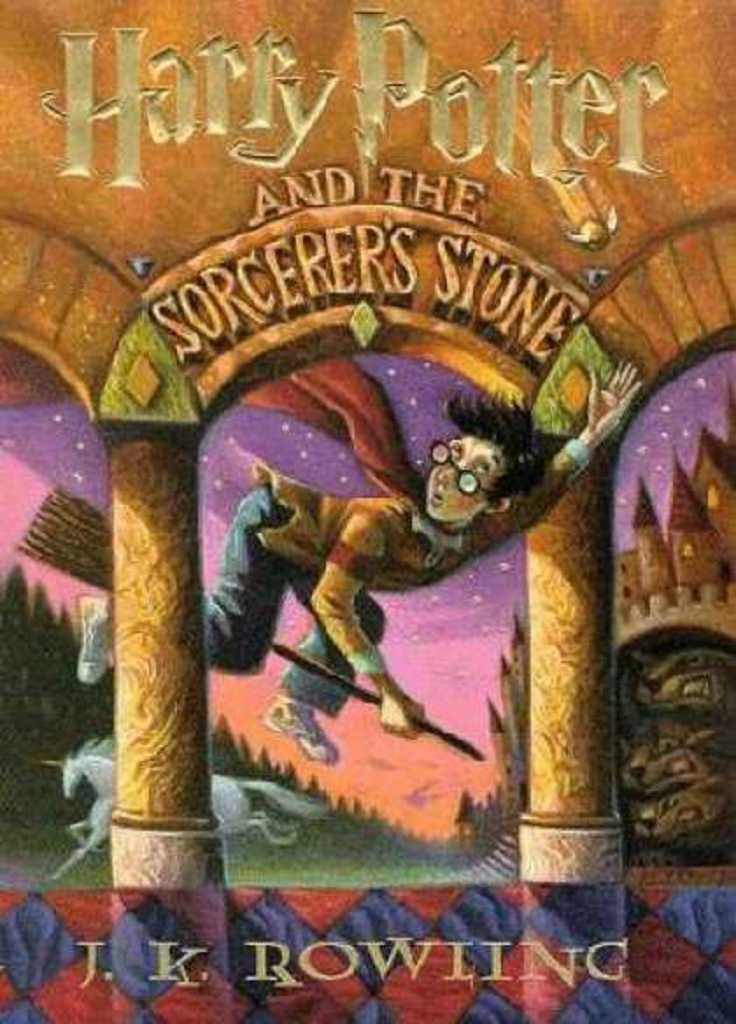<image>
Describe the image concisely. A Harry Potter book with Harry on the cover using a magical broom. 